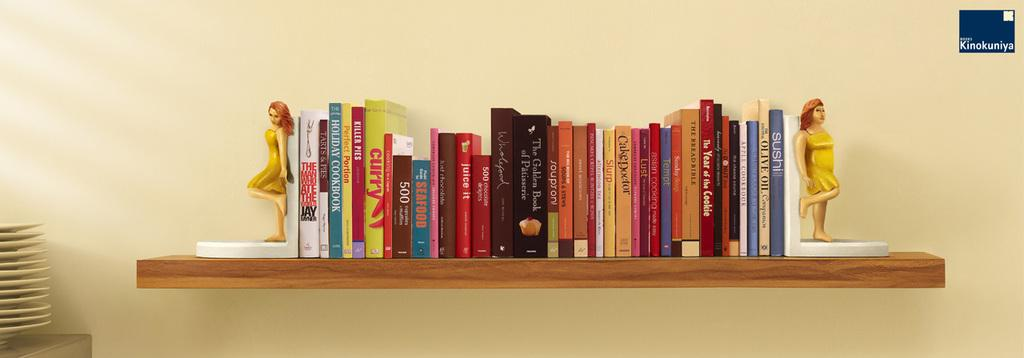<image>
Give a short and clear explanation of the subsequent image. A shelf filled with cookbooks with one titled Holiday Cookbook. 